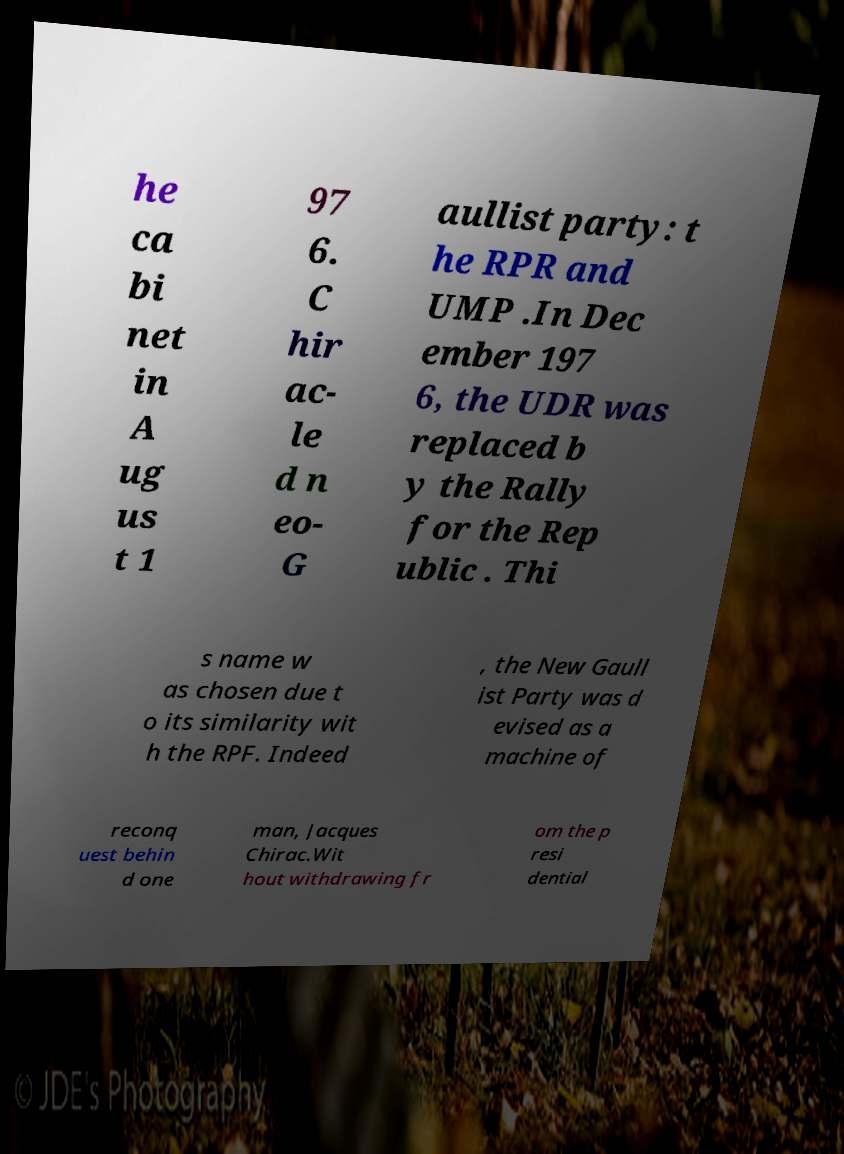Please read and relay the text visible in this image. What does it say? he ca bi net in A ug us t 1 97 6. C hir ac- le d n eo- G aullist party: t he RPR and UMP .In Dec ember 197 6, the UDR was replaced b y the Rally for the Rep ublic . Thi s name w as chosen due t o its similarity wit h the RPF. Indeed , the New Gaull ist Party was d evised as a machine of reconq uest behin d one man, Jacques Chirac.Wit hout withdrawing fr om the p resi dential 